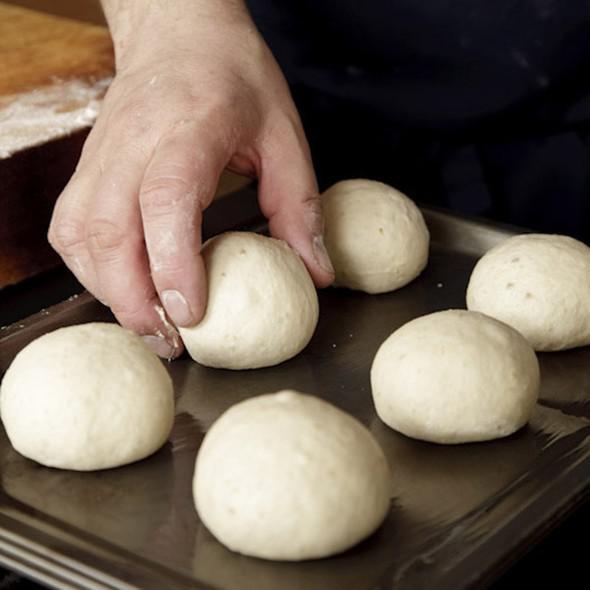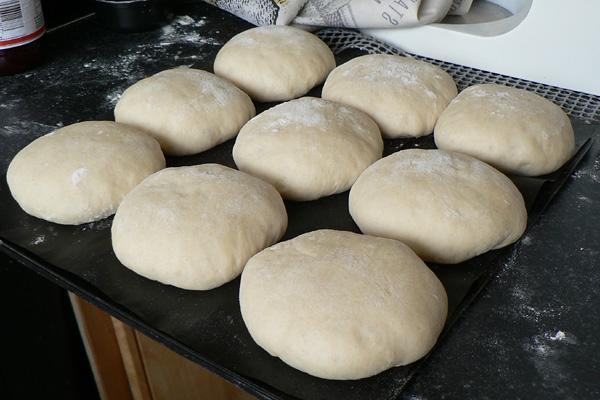The first image is the image on the left, the second image is the image on the right. For the images shown, is this caption "One pan of dough has at least sixteen balls, and all pans have balls that are touching and not spaced out." true? Answer yes or no. No. The first image is the image on the left, the second image is the image on the right. For the images shown, is this caption "there are 6 balls of bread dough in a silver pan lined with parchment paper" true? Answer yes or no. No. 